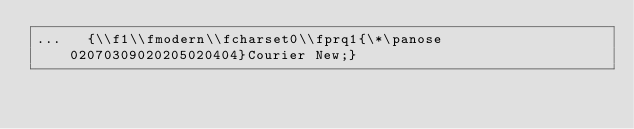Convert code to text. <code><loc_0><loc_0><loc_500><loc_500><_Python_>...   {\\f1\\fmodern\\fcharset0\\fprq1{\*\panose 02070309020205020404}Courier New;}</code> 